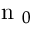Convert formula to latex. <formula><loc_0><loc_0><loc_500><loc_500>n _ { 0 }</formula> 